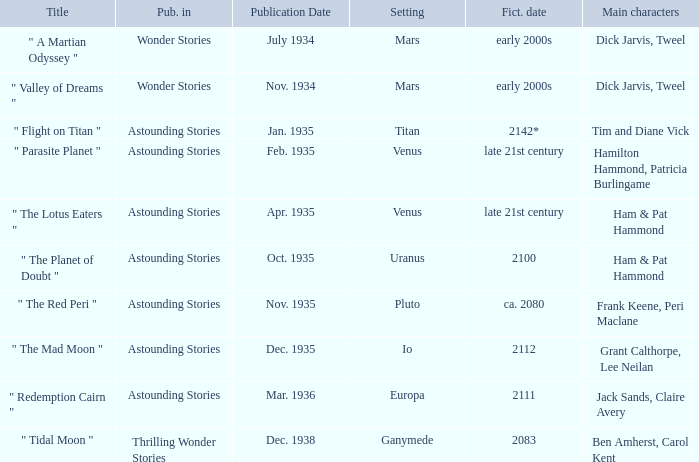Name what was published in july 1934 with a setting of mars Wonder Stories. 